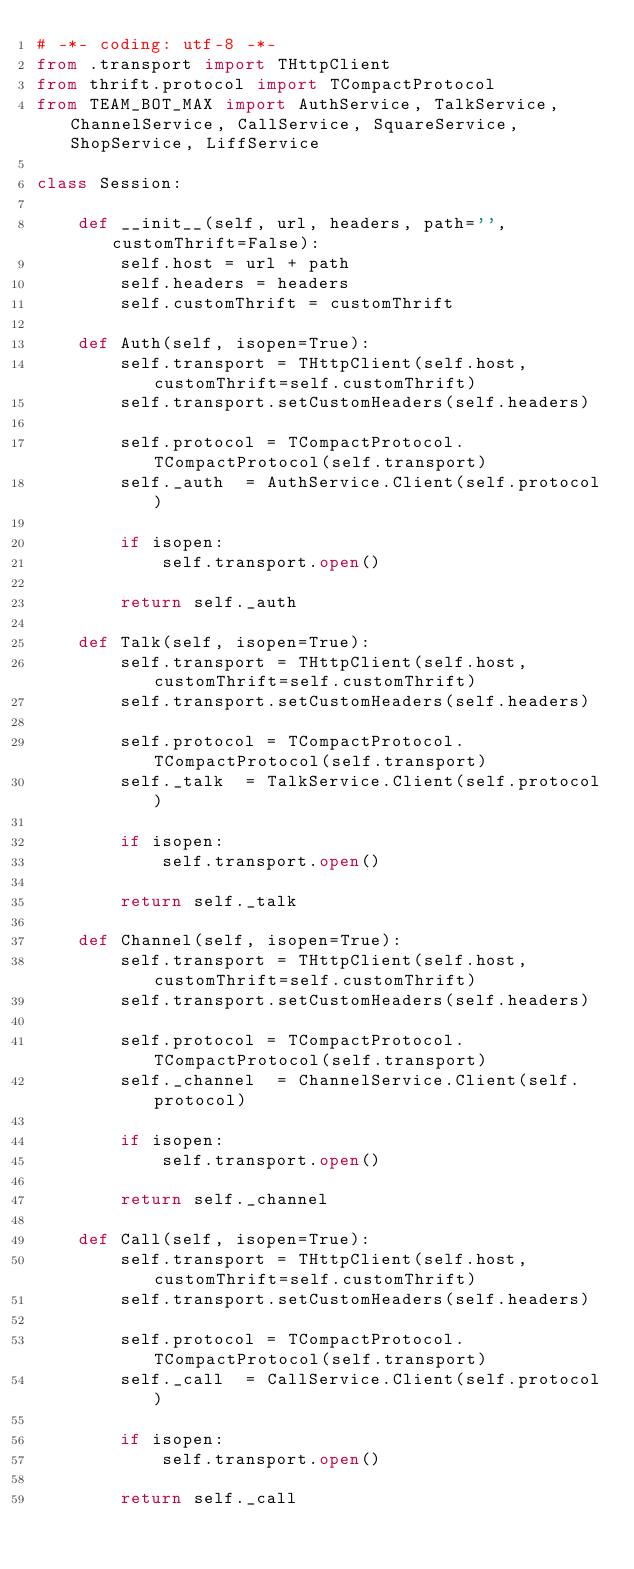Convert code to text. <code><loc_0><loc_0><loc_500><loc_500><_Python_># -*- coding: utf-8 -*-
from .transport import THttpClient
from thrift.protocol import TCompactProtocol
from TEAM_BOT_MAX import AuthService, TalkService, ChannelService, CallService, SquareService, ShopService, LiffService

class Session:

    def __init__(self, url, headers, path='', customThrift=False):
        self.host = url + path
        self.headers = headers
        self.customThrift = customThrift

    def Auth(self, isopen=True):
        self.transport = THttpClient(self.host, customThrift=self.customThrift)
        self.transport.setCustomHeaders(self.headers)
        
        self.protocol = TCompactProtocol.TCompactProtocol(self.transport)
        self._auth  = AuthService.Client(self.protocol)
        
        if isopen:
            self.transport.open()

        return self._auth

    def Talk(self, isopen=True):
        self.transport = THttpClient(self.host, customThrift=self.customThrift)
        self.transport.setCustomHeaders(self.headers)
        
        self.protocol = TCompactProtocol.TCompactProtocol(self.transport)
        self._talk  = TalkService.Client(self.protocol)
        
        if isopen:
            self.transport.open()

        return self._talk

    def Channel(self, isopen=True):
        self.transport = THttpClient(self.host, customThrift=self.customThrift)
        self.transport.setCustomHeaders(self.headers)

        self.protocol = TCompactProtocol.TCompactProtocol(self.transport)
        self._channel  = ChannelService.Client(self.protocol)
        
        if isopen:
            self.transport.open()

        return self._channel

    def Call(self, isopen=True):
        self.transport = THttpClient(self.host, customThrift=self.customThrift)
        self.transport.setCustomHeaders(self.headers)

        self.protocol = TCompactProtocol.TCompactProtocol(self.transport)
        self._call  = CallService.Client(self.protocol)
        
        if isopen:
            self.transport.open()

        return self._call
</code> 